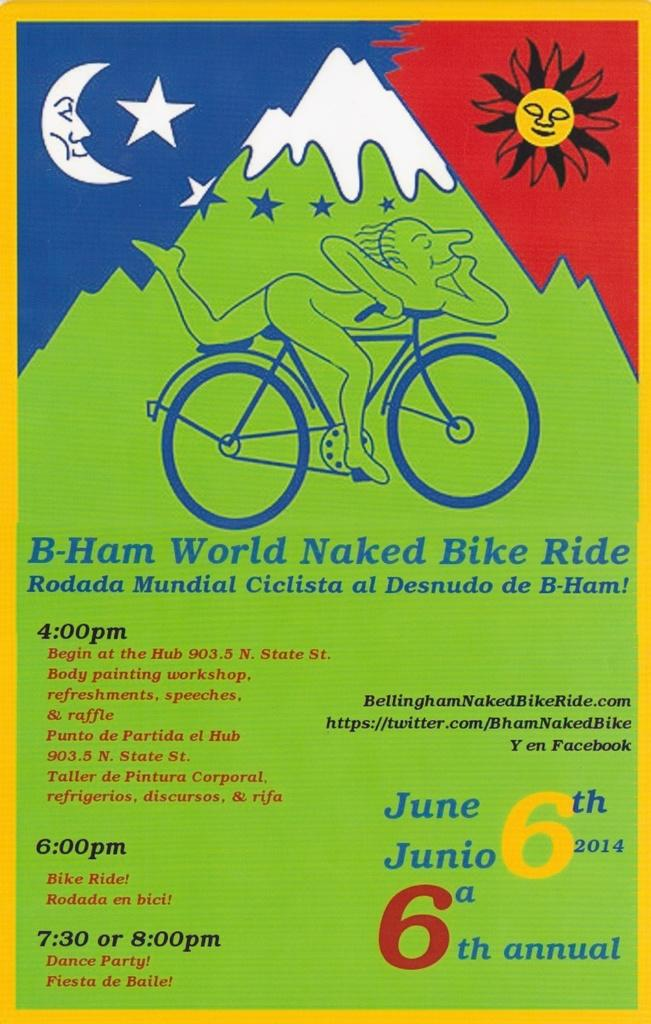<image>
Provide a brief description of the given image. An advertisement for a world naked bike ride that is in green, blue, white, and red. 